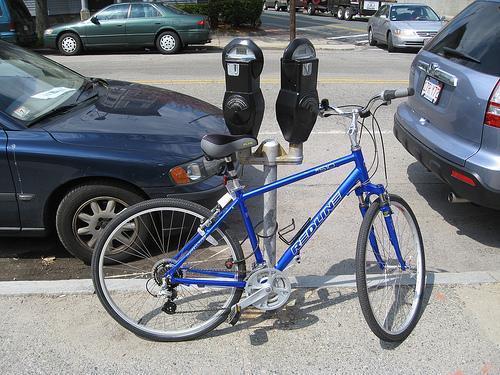How many of the vehicles are green?
Give a very brief answer. 1. 